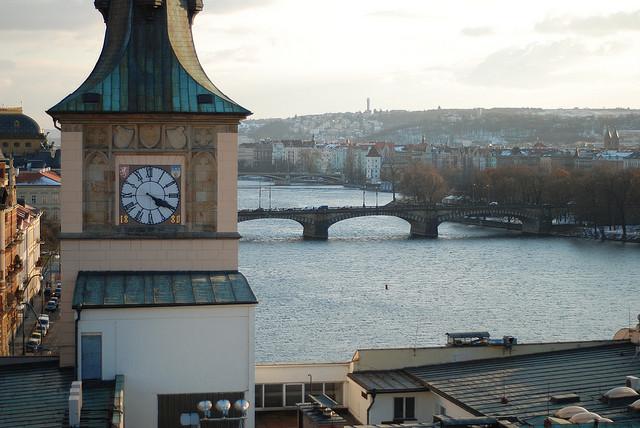What color is the roof above the clock?
Quick response, please. Green. What time is on the clock?
Write a very short answer. 4:20. Is the water deep?
Quick response, please. Yes. Is it morning or afternoon?
Write a very short answer. Afternoon. Does the clock have hands?
Quick response, please. Yes. 